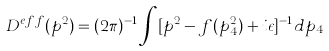<formula> <loc_0><loc_0><loc_500><loc_500>D ^ { e f f } ( p ^ { 2 } ) = ( 2 \pi ) ^ { - 1 } \int [ p ^ { 2 } - f ( p ^ { 2 } _ { 4 } ) + i \epsilon ] ^ { - 1 } d p _ { 4 }</formula> 